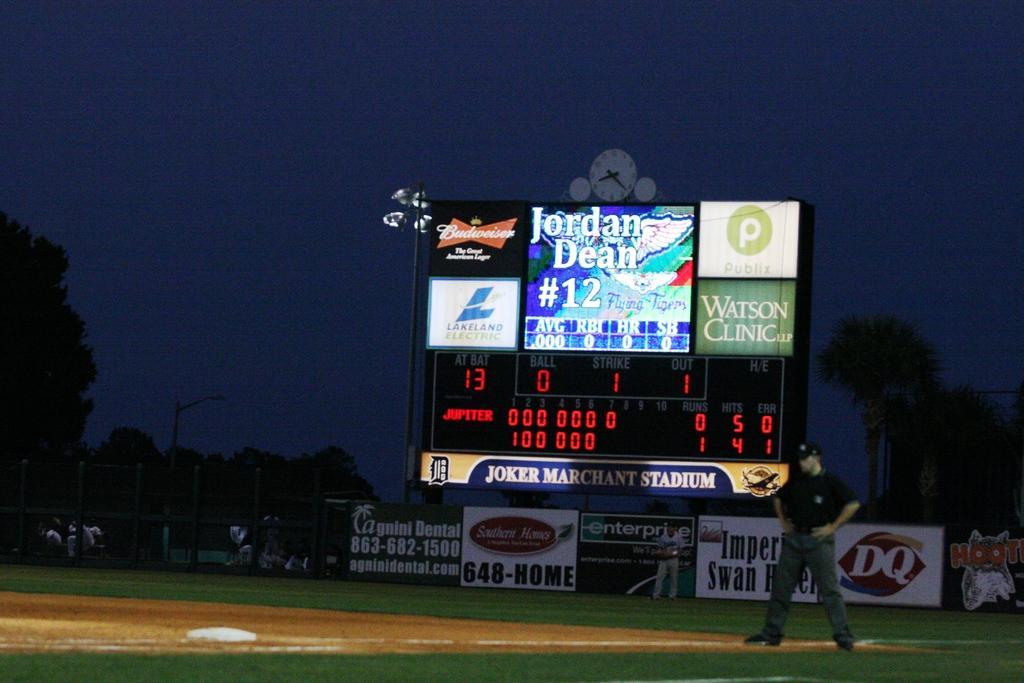Please provide a concise description of this image. In this picture there is a man on the right side of the image and there are posters, which are placed on the boundary and there is a big screen in the center of the image and there are trees in the background area of the image. 